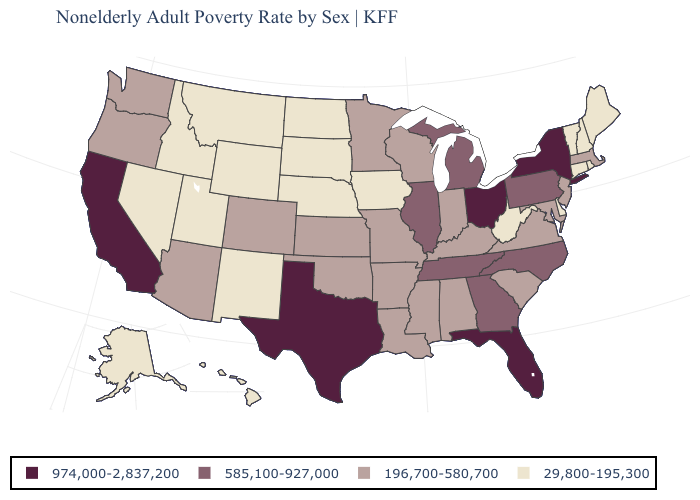What is the value of California?
Quick response, please. 974,000-2,837,200. Is the legend a continuous bar?
Keep it brief. No. Does South Carolina have the same value as Virginia?
Give a very brief answer. Yes. Name the states that have a value in the range 196,700-580,700?
Write a very short answer. Alabama, Arizona, Arkansas, Colorado, Indiana, Kansas, Kentucky, Louisiana, Maryland, Massachusetts, Minnesota, Mississippi, Missouri, New Jersey, Oklahoma, Oregon, South Carolina, Virginia, Washington, Wisconsin. Which states have the lowest value in the South?
Be succinct. Delaware, West Virginia. Which states have the lowest value in the West?
Keep it brief. Alaska, Hawaii, Idaho, Montana, Nevada, New Mexico, Utah, Wyoming. Name the states that have a value in the range 29,800-195,300?
Concise answer only. Alaska, Connecticut, Delaware, Hawaii, Idaho, Iowa, Maine, Montana, Nebraska, Nevada, New Hampshire, New Mexico, North Dakota, Rhode Island, South Dakota, Utah, Vermont, West Virginia, Wyoming. What is the value of Minnesota?
Short answer required. 196,700-580,700. Among the states that border South Dakota , which have the highest value?
Concise answer only. Minnesota. Which states have the lowest value in the MidWest?
Answer briefly. Iowa, Nebraska, North Dakota, South Dakota. Name the states that have a value in the range 585,100-927,000?
Short answer required. Georgia, Illinois, Michigan, North Carolina, Pennsylvania, Tennessee. What is the value of Missouri?
Quick response, please. 196,700-580,700. What is the value of Oklahoma?
Keep it brief. 196,700-580,700. Does the map have missing data?
Concise answer only. No. 